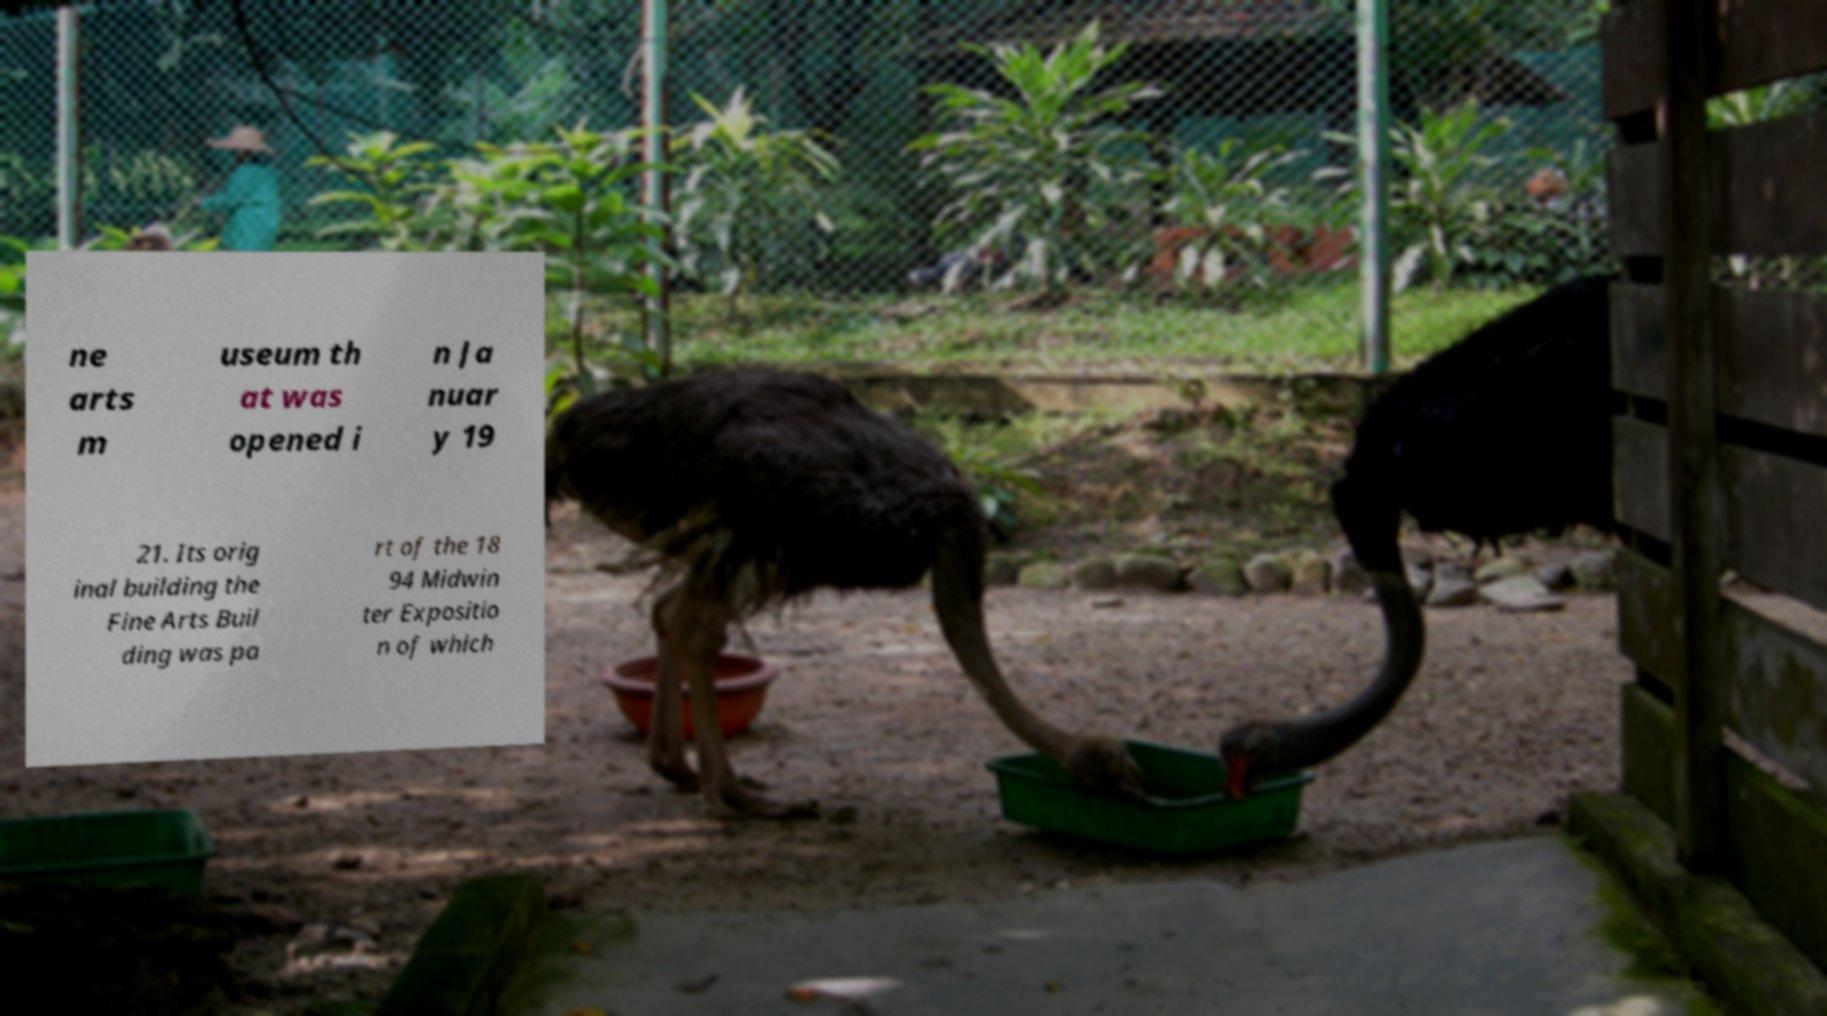Could you extract and type out the text from this image? ne arts m useum th at was opened i n Ja nuar y 19 21. Its orig inal building the Fine Arts Buil ding was pa rt of the 18 94 Midwin ter Expositio n of which 